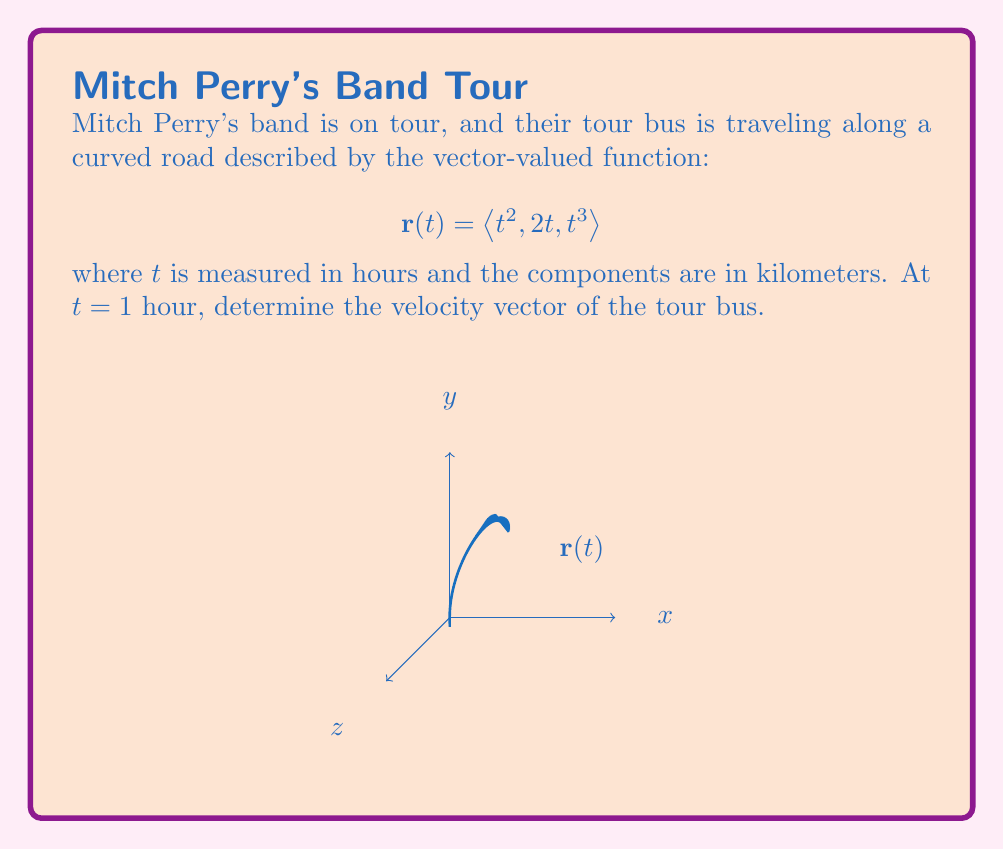Teach me how to tackle this problem. To find the velocity vector, we need to differentiate the position vector $\mathbf{r}(t)$ with respect to time. The velocity vector is given by $\mathbf{v}(t) = \frac{d\mathbf{r}}{dt}$.

Step 1: Differentiate each component of $\mathbf{r}(t)$:
$$\begin{align*}
\frac{d}{dt}(t^2) &= 2t \\
\frac{d}{dt}(2t) &= 2 \\
\frac{d}{dt}(t^3) &= 3t^2
\end{align*}$$

Step 2: Write the velocity vector function:
$$\mathbf{v}(t) = \langle 2t, 2, 3t^2 \rangle$$

Step 3: Evaluate $\mathbf{v}(t)$ at $t = 1$:
$$\begin{align*}
\mathbf{v}(1) &= \langle 2(1), 2, 3(1)^2 \rangle \\
&= \langle 2, 2, 3 \rangle
\end{align*}$$

Therefore, the velocity vector of the tour bus at $t = 1$ hour is $\langle 2, 2, 3 \rangle$ km/hr.
Answer: $\langle 2, 2, 3 \rangle$ km/hr 